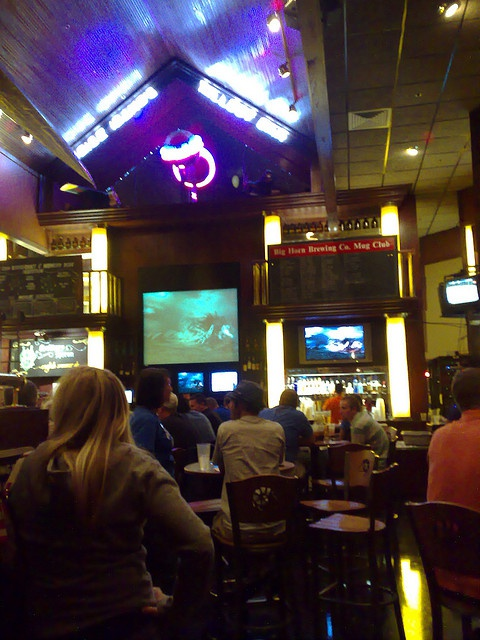Describe the objects in this image and their specific colors. I can see people in black, maroon, and olive tones, chair in black, maroon, olive, and gray tones, chair in black, maroon, and purple tones, tv in black, turquoise, and olive tones, and people in black, olive, and maroon tones in this image. 